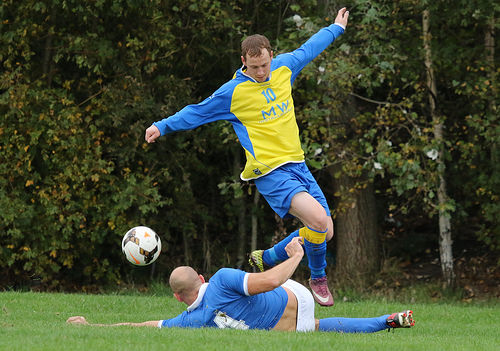<image>
Is there a man under the man? Yes. The man is positioned underneath the man, with the man above it in the vertical space. 